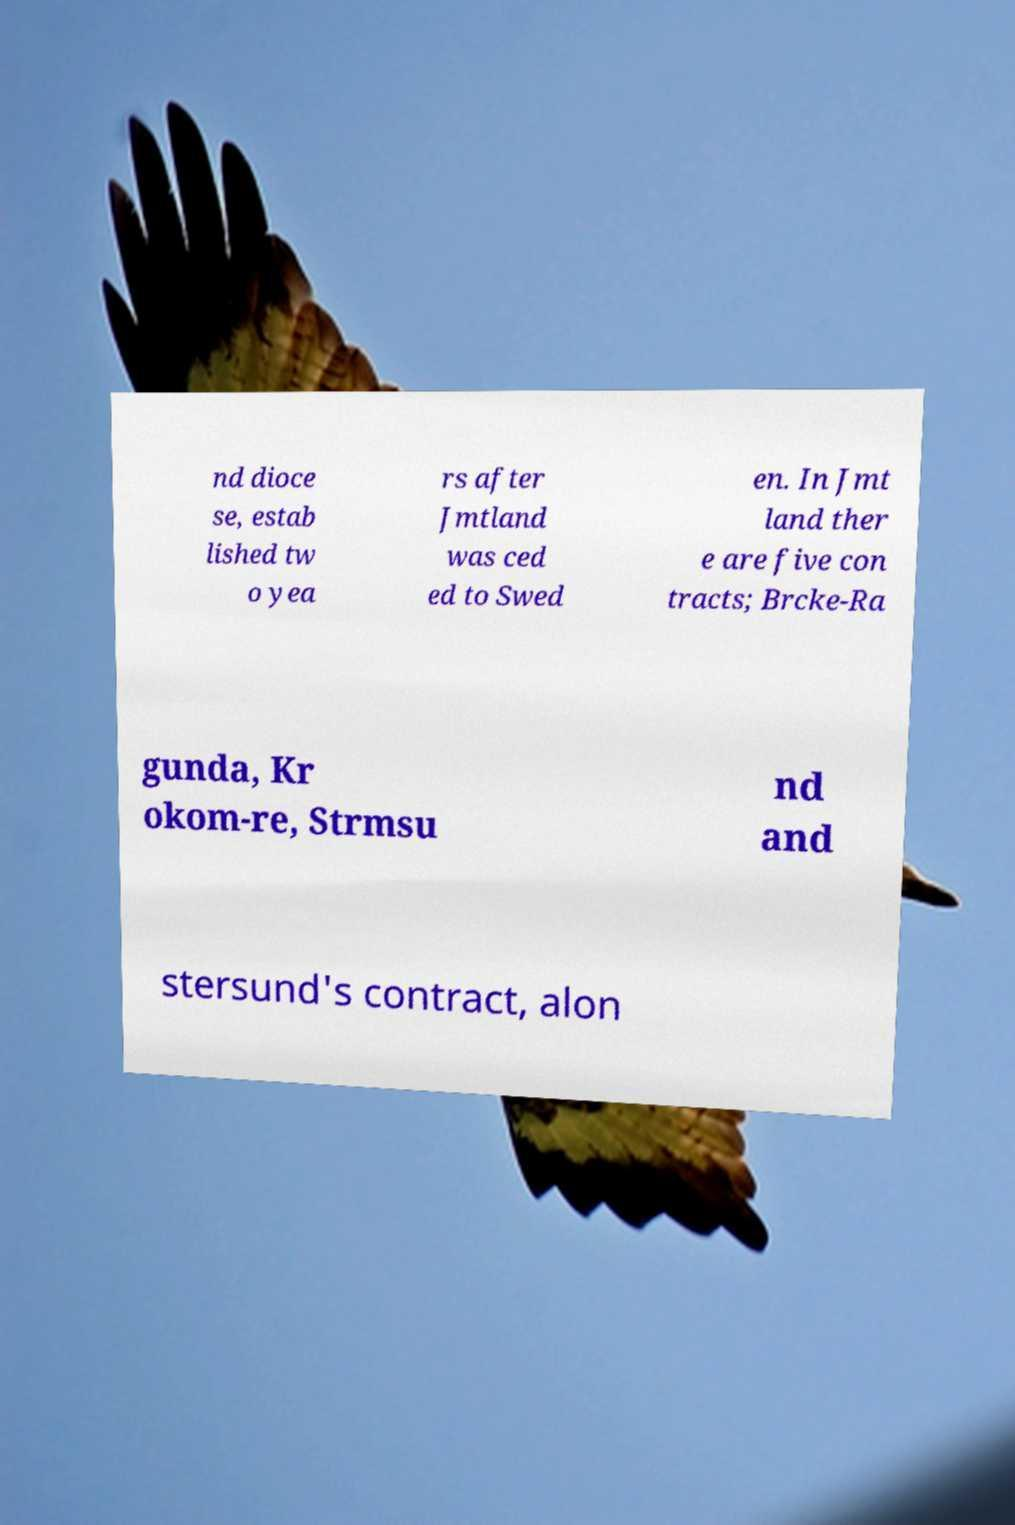I need the written content from this picture converted into text. Can you do that? nd dioce se, estab lished tw o yea rs after Jmtland was ced ed to Swed en. In Jmt land ther e are five con tracts; Brcke-Ra gunda, Kr okom-re, Strmsu nd and stersund's contract, alon 